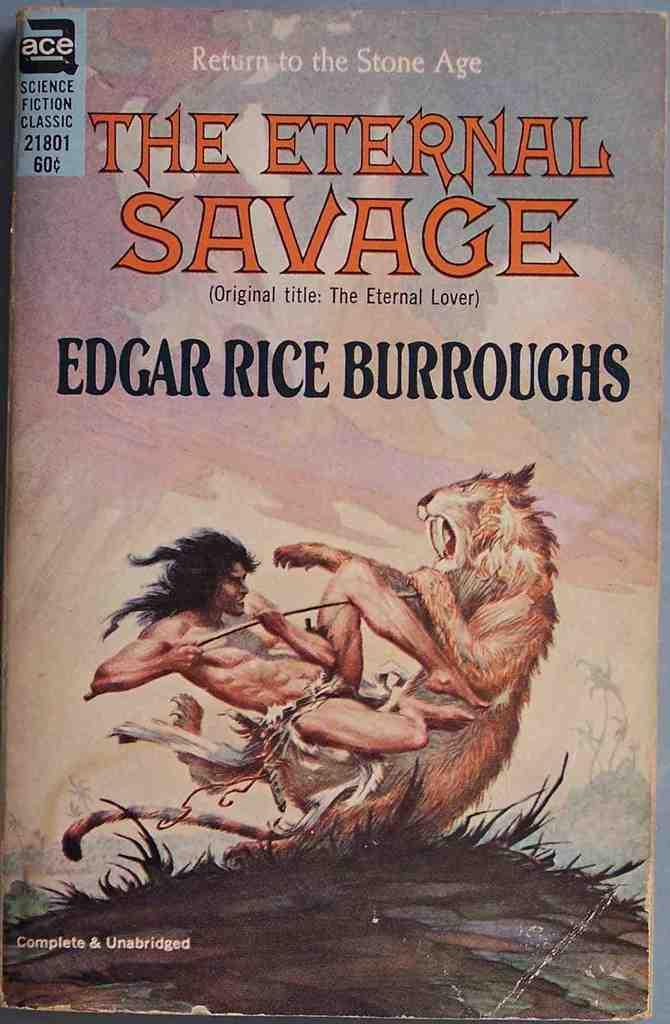What is the genre of this book?
Provide a succinct answer. Science fiction. Who wrote this book?
Offer a very short reply. Edgar rice burroughs. 